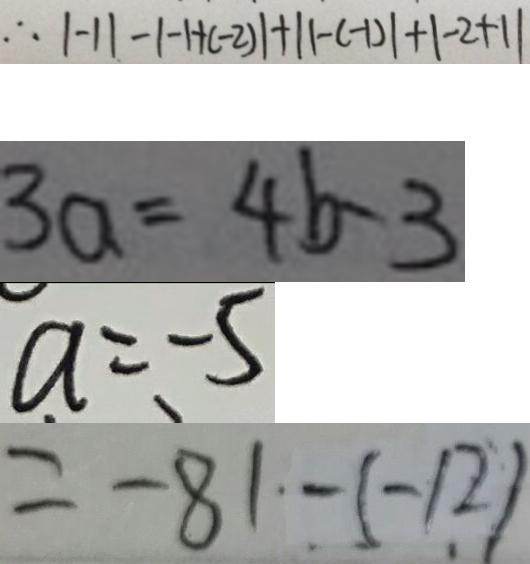<formula> <loc_0><loc_0><loc_500><loc_500>\therefore \vert - 1 \vert - \vert - 1 + ( - 2 ) \vert + \vert 1 - ( - 1 ) \vert + \vert - 2 + 1 \vert 
 3 a = 4 b - 3 
 a = - 5 
 = - 8 1 - ( - 1 2 )</formula> 